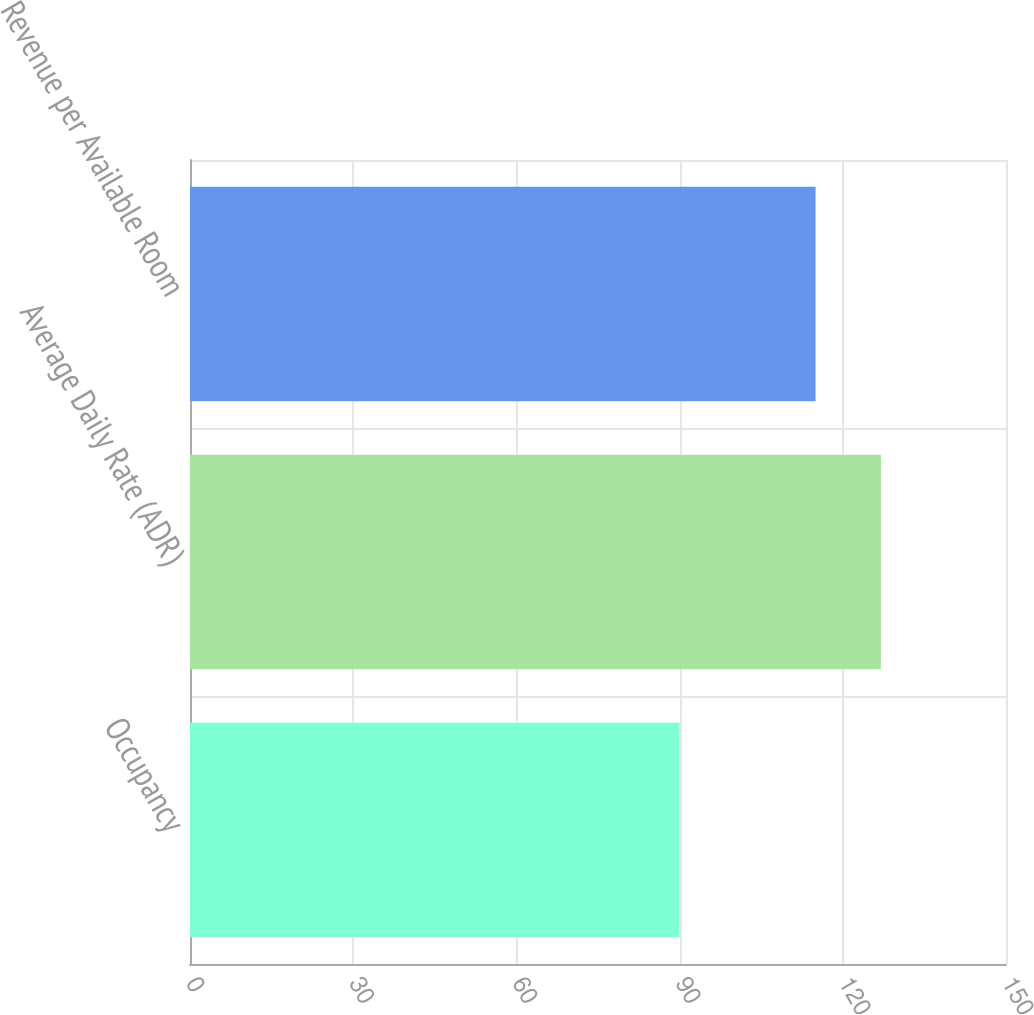Convert chart. <chart><loc_0><loc_0><loc_500><loc_500><bar_chart><fcel>Occupancy<fcel>Average Daily Rate (ADR)<fcel>Revenue per Available Room<nl><fcel>90<fcel>127<fcel>115<nl></chart> 